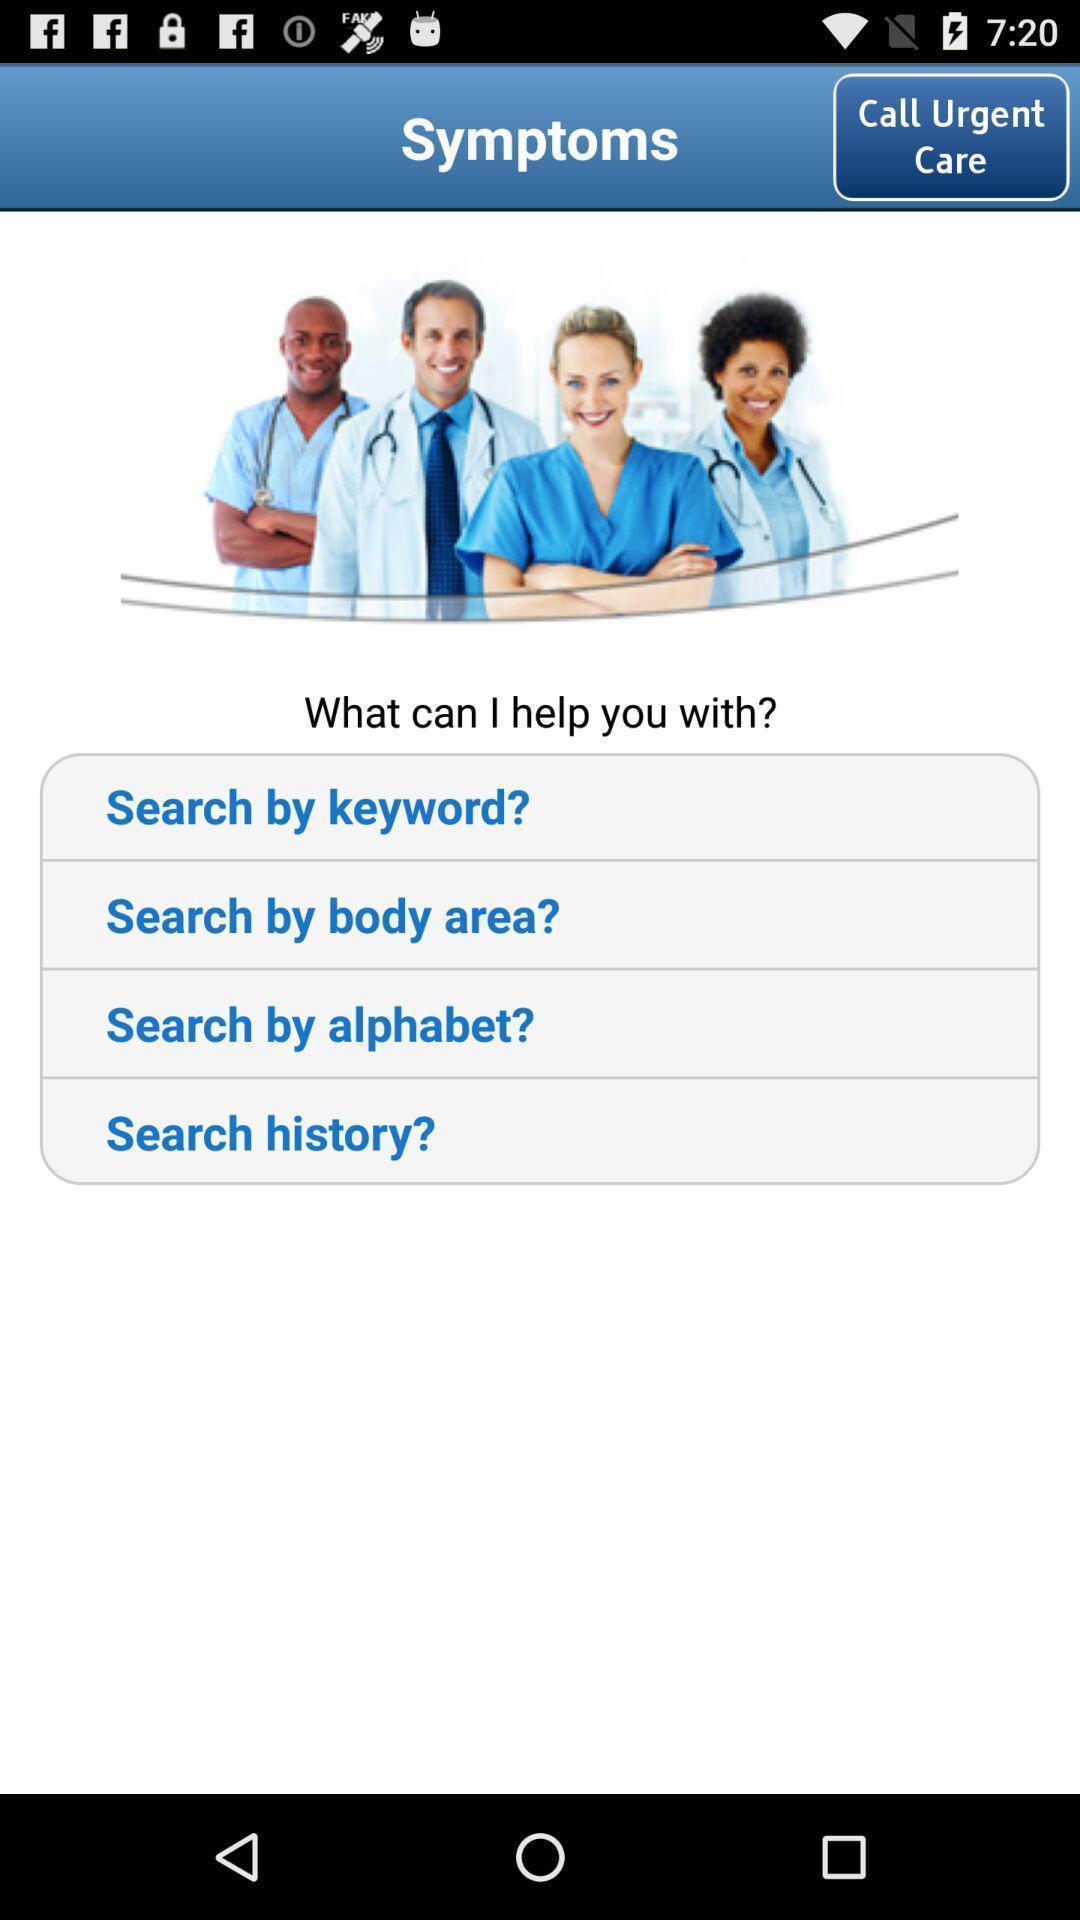Provide a detailed account of this screenshot. Screen displaying multiple search options in health application. 